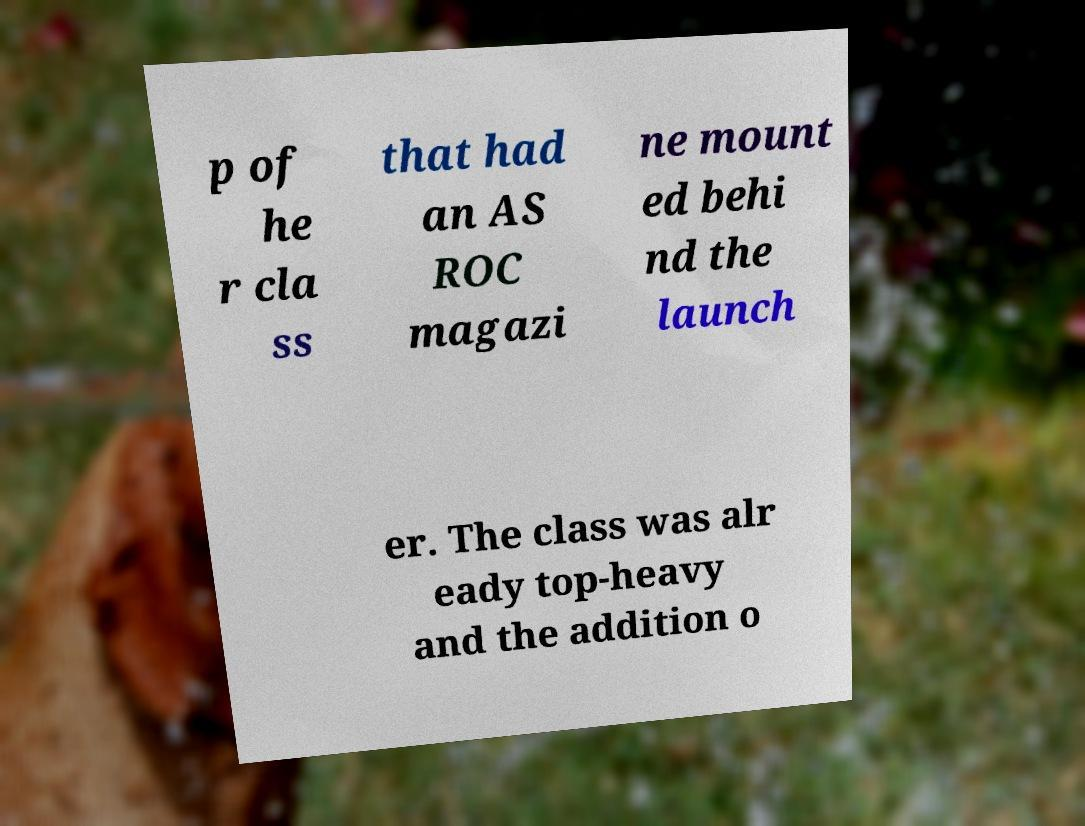There's text embedded in this image that I need extracted. Can you transcribe it verbatim? p of he r cla ss that had an AS ROC magazi ne mount ed behi nd the launch er. The class was alr eady top-heavy and the addition o 